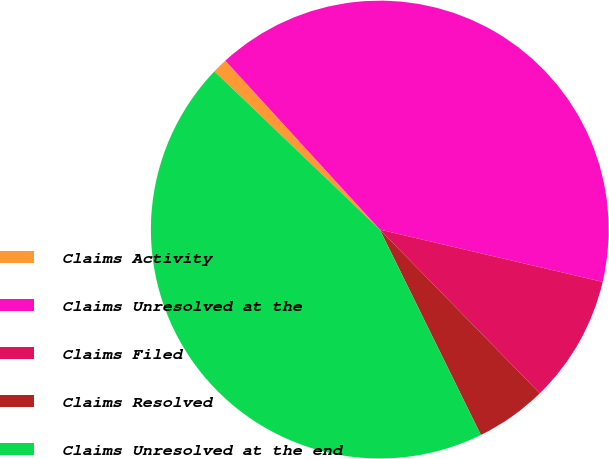Convert chart to OTSL. <chart><loc_0><loc_0><loc_500><loc_500><pie_chart><fcel>Claims Activity<fcel>Claims Unresolved at the<fcel>Claims Filed<fcel>Claims Resolved<fcel>Claims Unresolved at the end<nl><fcel>1.06%<fcel>40.46%<fcel>9.01%<fcel>5.04%<fcel>44.43%<nl></chart> 